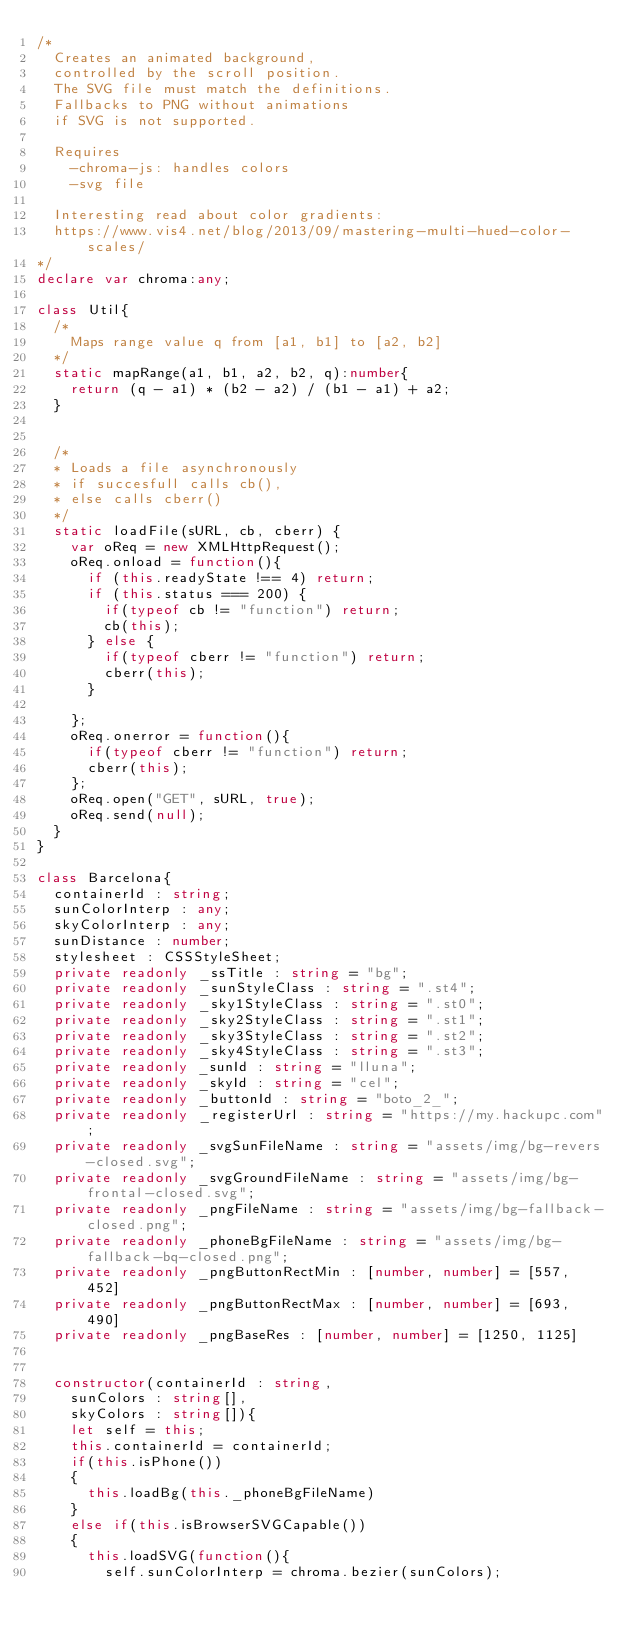Convert code to text. <code><loc_0><loc_0><loc_500><loc_500><_TypeScript_>/*
	Creates an animated background,
	controlled by the scroll position.
	The SVG file must match the definitions.
	Fallbacks to PNG without animations
	if SVG is not supported.

	Requires
		-chroma-js: handles colors
		-svg file

	Interesting read about color gradients:
	https://www.vis4.net/blog/2013/09/mastering-multi-hued-color-scales/
*/
declare var chroma:any;

class Util{
	/*
		Maps range value q from [a1, b1] to [a2, b2]
	*/
	static mapRange(a1, b1, a2, b2, q):number{
		return (q - a1) * (b2 - a2) / (b1 - a1) + a2;
	}


	/*
	* Loads a file asynchronously
	* if succesfull calls cb(),
	* else calls cberr()
	*/
	static loadFile(sURL, cb, cberr) {
		var oReq = new XMLHttpRequest();
		oReq.onload = function(){
			if (this.readyState !== 4) return;
			if (this.status === 200) {
				if(typeof cb != "function") return;
				cb(this);
			} else {
				if(typeof cberr != "function") return;
				cberr(this);
			}
			
		};
		oReq.onerror = function(){
			if(typeof cberr != "function") return;
			cberr(this);
		};
		oReq.open("GET", sURL, true);
		oReq.send(null);
	}
}

class Barcelona{
	containerId : string;
	sunColorInterp : any;
	skyColorInterp : any;
	sunDistance : number;
	stylesheet : CSSStyleSheet;
	private readonly _ssTitle : string = "bg";
	private readonly _sunStyleClass : string = ".st4";
	private readonly _sky1StyleClass : string = ".st0";
	private readonly _sky2StyleClass : string = ".st1";
	private readonly _sky3StyleClass : string = ".st2";
	private readonly _sky4StyleClass : string = ".st3";
	private readonly _sunId : string = "lluna";
	private readonly _skyId : string = "cel";
	private readonly _buttonId : string = "boto_2_";
	private readonly _registerUrl : string = "https://my.hackupc.com";
	private readonly _svgSunFileName : string = "assets/img/bg-revers-closed.svg";
	private readonly _svgGroundFileName : string = "assets/img/bg-frontal-closed.svg";
	private readonly _pngFileName : string = "assets/img/bg-fallback-closed.png";
	private readonly _phoneBgFileName : string = "assets/img/bg-fallback-bq-closed.png";
	private readonly _pngButtonRectMin : [number, number] = [557, 452]
	private readonly _pngButtonRectMax : [number, number] = [693, 490]
	private readonly _pngBaseRes : [number, number] = [1250, 1125]


	constructor(containerId : string, 
		sunColors : string[],
		skyColors : string[]){
		let self = this;
		this.containerId = containerId;
		if(this.isPhone())
		{
			this.loadBg(this._phoneBgFileName)
		}
		else if(this.isBrowserSVGCapable())
		{
			this.loadSVG(function(){
				self.sunColorInterp = chroma.bezier(sunColors);</code> 